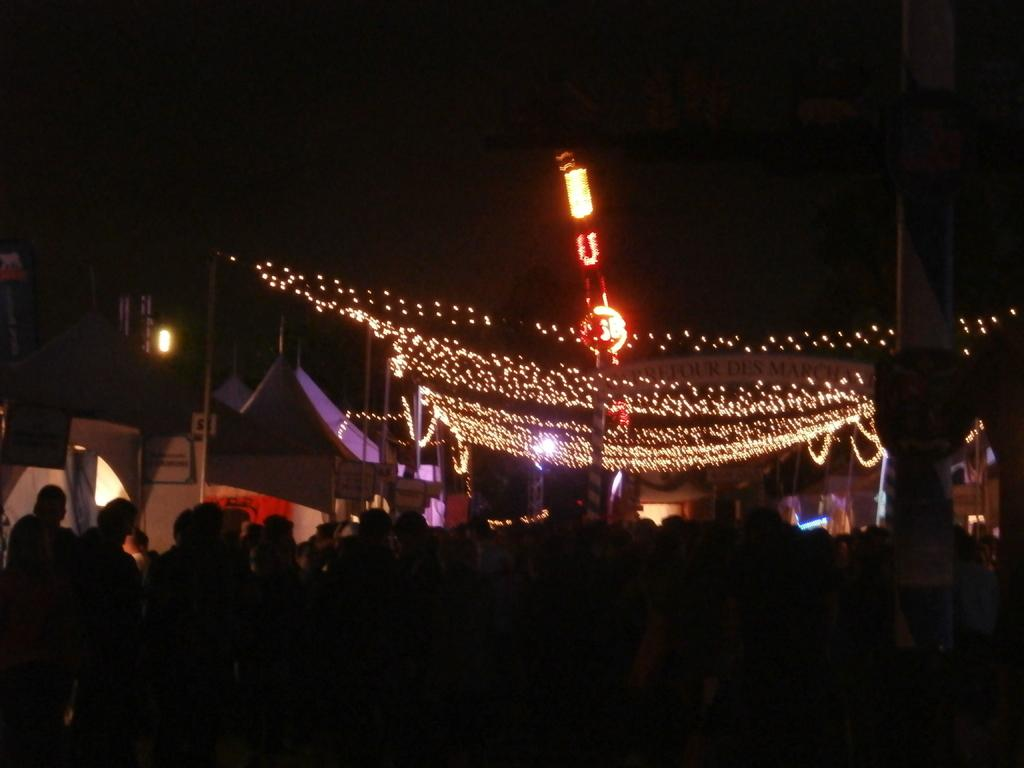What is the overall lighting condition in the image? The image is dark. Where are the people located in the image? The people are at the bottom of the image. What can be seen in the background of the image? There are decorative lights, poles, and other objects in the background of the image. What type of mark can be seen on the behavior of the people in the image? There is no mention of any mark or behavior of the people in the image. The image only shows people at the bottom and decorative lights, poles, and other objects in the background. 